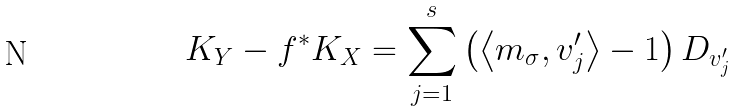<formula> <loc_0><loc_0><loc_500><loc_500>K _ { Y } - f ^ { \ast } K _ { X } = \sum _ { j = 1 } ^ { s } \left ( \left \langle m _ { \sigma } , v _ { j } ^ { \prime } \right \rangle - 1 \right ) D _ { v _ { j } ^ { \prime } }</formula> 